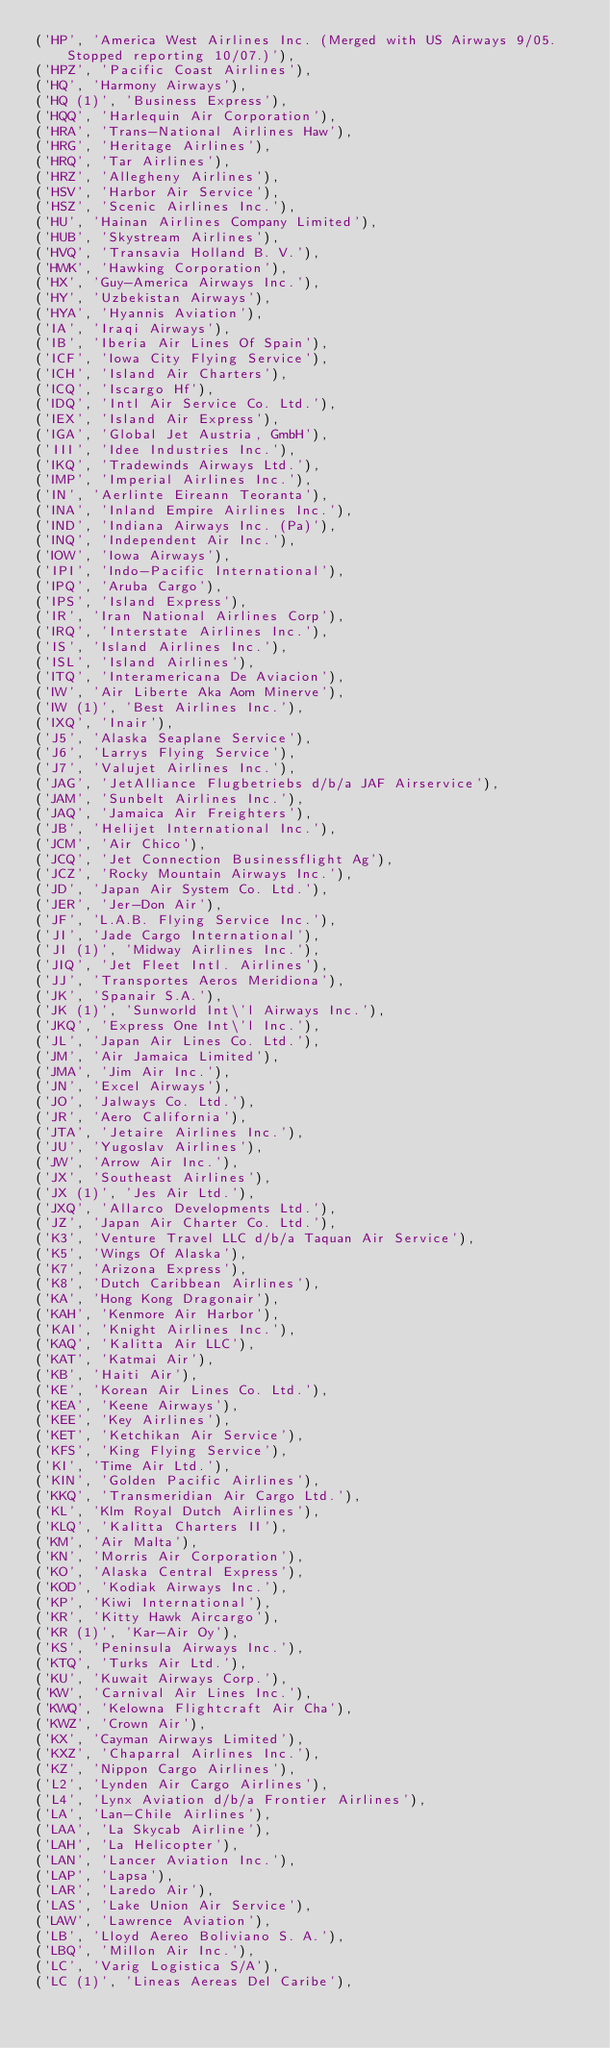Convert code to text. <code><loc_0><loc_0><loc_500><loc_500><_SQL_>('HP', 'America West Airlines Inc. (Merged with US Airways 9/05. Stopped reporting 10/07.)'),
('HPZ', 'Pacific Coast Airlines'),
('HQ', 'Harmony Airways'),
('HQ (1)', 'Business Express'),
('HQQ', 'Harlequin Air Corporation'),
('HRA', 'Trans-National Airlines Haw'),
('HRG', 'Heritage Airlines'),
('HRQ', 'Tar Airlines'),
('HRZ', 'Allegheny Airlines'),
('HSV', 'Harbor Air Service'),
('HSZ', 'Scenic Airlines Inc.'),
('HU', 'Hainan Airlines Company Limited'),
('HUB', 'Skystream Airlines'),
('HVQ', 'Transavia Holland B. V.'),
('HWK', 'Hawking Corporation'),
('HX', 'Guy-America Airways Inc.'),
('HY', 'Uzbekistan Airways'),
('HYA', 'Hyannis Aviation'),
('IA', 'Iraqi Airways'),
('IB', 'Iberia Air Lines Of Spain'),
('ICF', 'Iowa City Flying Service'),
('ICH', 'Island Air Charters'),
('ICQ', 'Iscargo Hf'),
('IDQ', 'Intl Air Service Co. Ltd.'),
('IEX', 'Island Air Express'),
('IGA', 'Global Jet Austria, GmbH'),
('III', 'Idee Industries Inc.'),
('IKQ', 'Tradewinds Airways Ltd.'),
('IMP', 'Imperial Airlines Inc.'),
('IN', 'Aerlinte Eireann Teoranta'),
('INA', 'Inland Empire Airlines Inc.'),
('IND', 'Indiana Airways Inc. (Pa)'),
('INQ', 'Independent Air Inc.'),
('IOW', 'Iowa Airways'),
('IPI', 'Indo-Pacific International'),
('IPQ', 'Aruba Cargo'),
('IPS', 'Island Express'),
('IR', 'Iran National Airlines Corp'),
('IRQ', 'Interstate Airlines Inc.'),
('IS', 'Island Airlines Inc.'),
('ISL', 'Island Airlines'),
('ITQ', 'Interamericana De Aviacion'),
('IW', 'Air Liberte Aka Aom Minerve'),
('IW (1)', 'Best Airlines Inc.'),
('IXQ', 'Inair'),
('J5', 'Alaska Seaplane Service'),
('J6', 'Larrys Flying Service'),
('J7', 'Valujet Airlines Inc.'),
('JAG', 'JetAlliance Flugbetriebs d/b/a JAF Airservice'),
('JAM', 'Sunbelt Airlines Inc.'),
('JAQ', 'Jamaica Air Freighters'),
('JB', 'Helijet International Inc.'),
('JCM', 'Air Chico'),
('JCQ', 'Jet Connection Businessflight Ag'),
('JCZ', 'Rocky Mountain Airways Inc.'),
('JD', 'Japan Air System Co. Ltd.'),
('JER', 'Jer-Don Air'),
('JF', 'L.A.B. Flying Service Inc.'),
('JI', 'Jade Cargo International'),
('JI (1)', 'Midway Airlines Inc.'),
('JIQ', 'Jet Fleet Intl. Airlines'),
('JJ', 'Transportes Aeros Meridiona'),
('JK', 'Spanair S.A.'),
('JK (1)', 'Sunworld Int\'l Airways Inc.'),
('JKQ', 'Express One Int\'l Inc.'),
('JL', 'Japan Air Lines Co. Ltd.'),
('JM', 'Air Jamaica Limited'),
('JMA', 'Jim Air Inc.'),
('JN', 'Excel Airways'),
('JO', 'Jalways Co. Ltd.'),
('JR', 'Aero California'),
('JTA', 'Jetaire Airlines Inc.'),
('JU', 'Yugoslav Airlines'),
('JW', 'Arrow Air Inc.'),
('JX', 'Southeast Airlines'),
('JX (1)', 'Jes Air Ltd.'),
('JXQ', 'Allarco Developments Ltd.'),
('JZ', 'Japan Air Charter Co. Ltd.'),
('K3', 'Venture Travel LLC d/b/a Taquan Air Service'),
('K5', 'Wings Of Alaska'),
('K7', 'Arizona Express'),
('K8', 'Dutch Caribbean Airlines'),
('KA', 'Hong Kong Dragonair'),
('KAH', 'Kenmore Air Harbor'),
('KAI', 'Knight Airlines Inc.'),
('KAQ', 'Kalitta Air LLC'),
('KAT', 'Katmai Air'),
('KB', 'Haiti Air'),
('KE', 'Korean Air Lines Co. Ltd.'),
('KEA', 'Keene Airways'),
('KEE', 'Key Airlines'),
('KET', 'Ketchikan Air Service'),
('KFS', 'King Flying Service'),
('KI', 'Time Air Ltd.'),
('KIN', 'Golden Pacific Airlines'),
('KKQ', 'Transmeridian Air Cargo Ltd.'),
('KL', 'Klm Royal Dutch Airlines'),
('KLQ', 'Kalitta Charters II'),
('KM', 'Air Malta'),
('KN', 'Morris Air Corporation'),
('KO', 'Alaska Central Express'),
('KOD', 'Kodiak Airways Inc.'),
('KP', 'Kiwi International'),
('KR', 'Kitty Hawk Aircargo'),
('KR (1)', 'Kar-Air Oy'),
('KS', 'Peninsula Airways Inc.'),
('KTQ', 'Turks Air Ltd.'),
('KU', 'Kuwait Airways Corp.'),
('KW', 'Carnival Air Lines Inc.'),
('KWQ', 'Kelowna Flightcraft Air Cha'),
('KWZ', 'Crown Air'),
('KX', 'Cayman Airways Limited'),
('KXZ', 'Chaparral Airlines Inc.'),
('KZ', 'Nippon Cargo Airlines'),
('L2', 'Lynden Air Cargo Airlines'),
('L4', 'Lynx Aviation d/b/a Frontier Airlines'),
('LA', 'Lan-Chile Airlines'),
('LAA', 'La Skycab Airline'),
('LAH', 'La Helicopter'),
('LAN', 'Lancer Aviation Inc.'),
('LAP', 'Lapsa'),
('LAR', 'Laredo Air'),
('LAS', 'Lake Union Air Service'),
('LAW', 'Lawrence Aviation'),
('LB', 'Lloyd Aereo Boliviano S. A.'),
('LBQ', 'Millon Air Inc.'),
('LC', 'Varig Logistica S/A'),
('LC (1)', 'Lineas Aereas Del Caribe'),</code> 